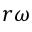Convert formula to latex. <formula><loc_0><loc_0><loc_500><loc_500>r \omega</formula> 